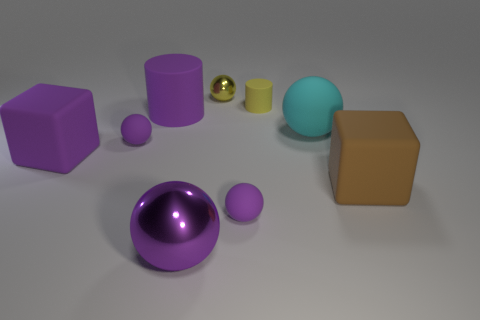Is there a big matte cube of the same color as the big cylinder?
Give a very brief answer. Yes. Is the big matte cylinder the same color as the large shiny ball?
Offer a terse response. Yes. What shape is the big metallic object that is the same color as the big rubber cylinder?
Give a very brief answer. Sphere. There is a metal sphere that is the same color as the big cylinder; what size is it?
Ensure brevity in your answer.  Large. There is a tiny purple rubber object that is on the left side of the tiny metallic ball right of the rubber cube left of the brown rubber thing; what shape is it?
Your answer should be compact. Sphere. How many things are either big matte blocks or purple objects in front of the big brown rubber object?
Make the answer very short. 4. There is a tiny object in front of the purple rubber block; is its shape the same as the small thing that is left of the large purple cylinder?
Your answer should be compact. Yes. What number of things are either blue cylinders or large matte things?
Make the answer very short. 4. Are there any large yellow shiny cylinders?
Provide a succinct answer. No. Is the material of the small ball in front of the big brown object the same as the yellow sphere?
Your response must be concise. No. 